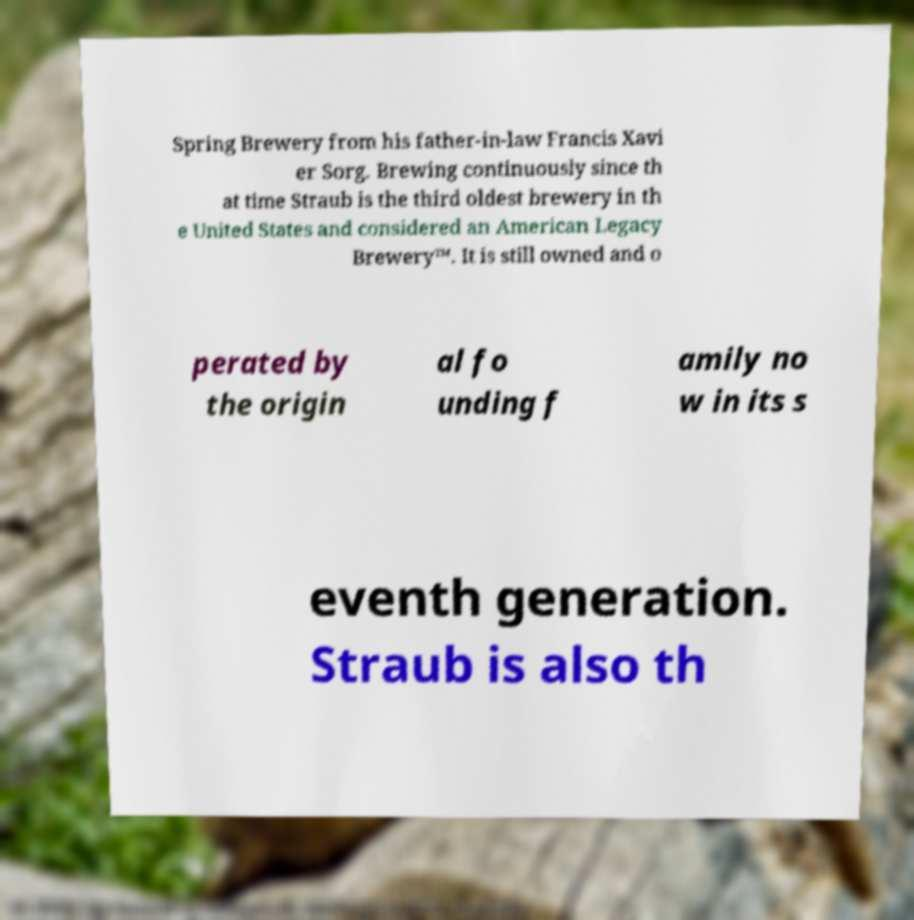There's text embedded in this image that I need extracted. Can you transcribe it verbatim? Spring Brewery from his father-in-law Francis Xavi er Sorg. Brewing continuously since th at time Straub is the third oldest brewery in th e United States and considered an American Legacy Brewery™. It is still owned and o perated by the origin al fo unding f amily no w in its s eventh generation. Straub is also th 